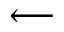<formula> <loc_0><loc_0><loc_500><loc_500>\longleftarrow</formula> 